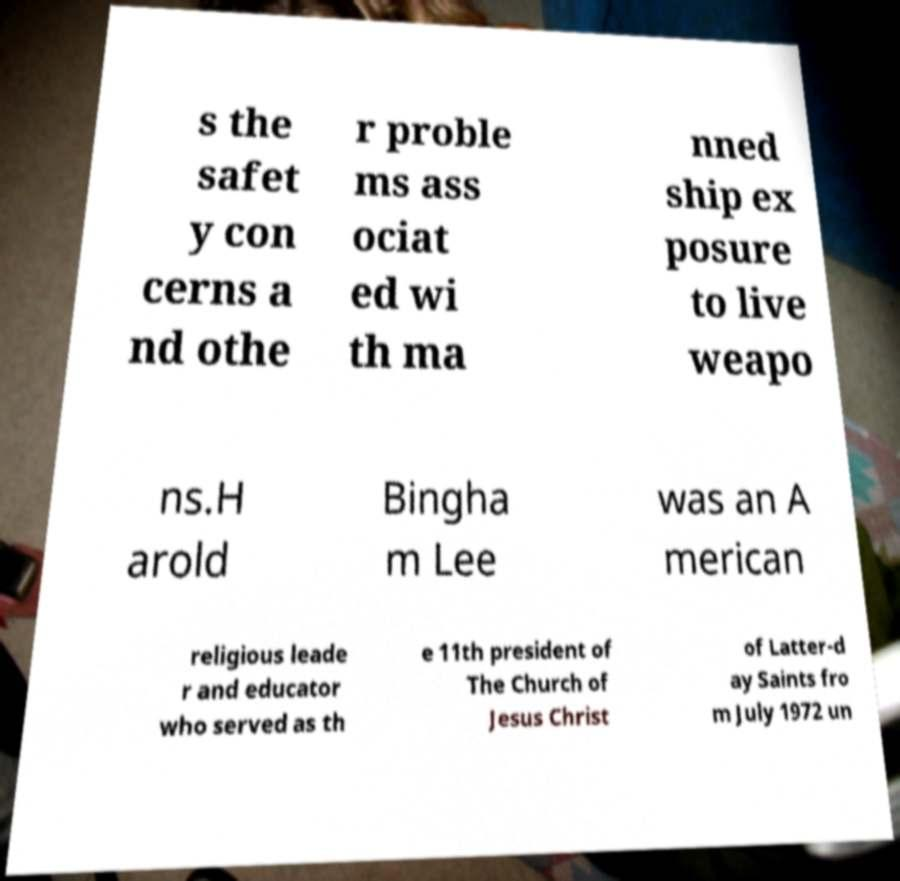I need the written content from this picture converted into text. Can you do that? s the safet y con cerns a nd othe r proble ms ass ociat ed wi th ma nned ship ex posure to live weapo ns.H arold Bingha m Lee was an A merican religious leade r and educator who served as th e 11th president of The Church of Jesus Christ of Latter-d ay Saints fro m July 1972 un 